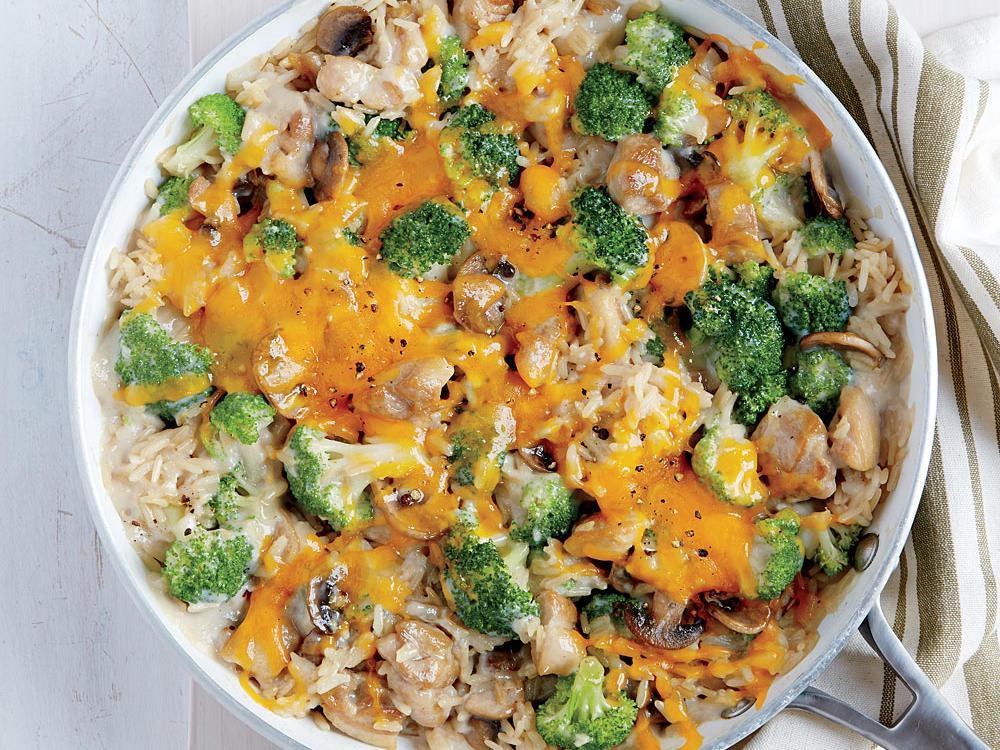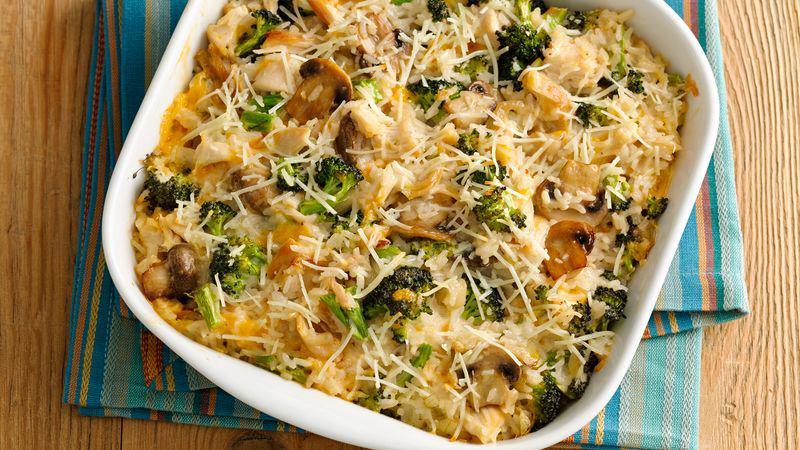The first image is the image on the left, the second image is the image on the right. Given the left and right images, does the statement "In one of the images there is a broccoli casserole with a large serving spoon in it." hold true? Answer yes or no. No. 